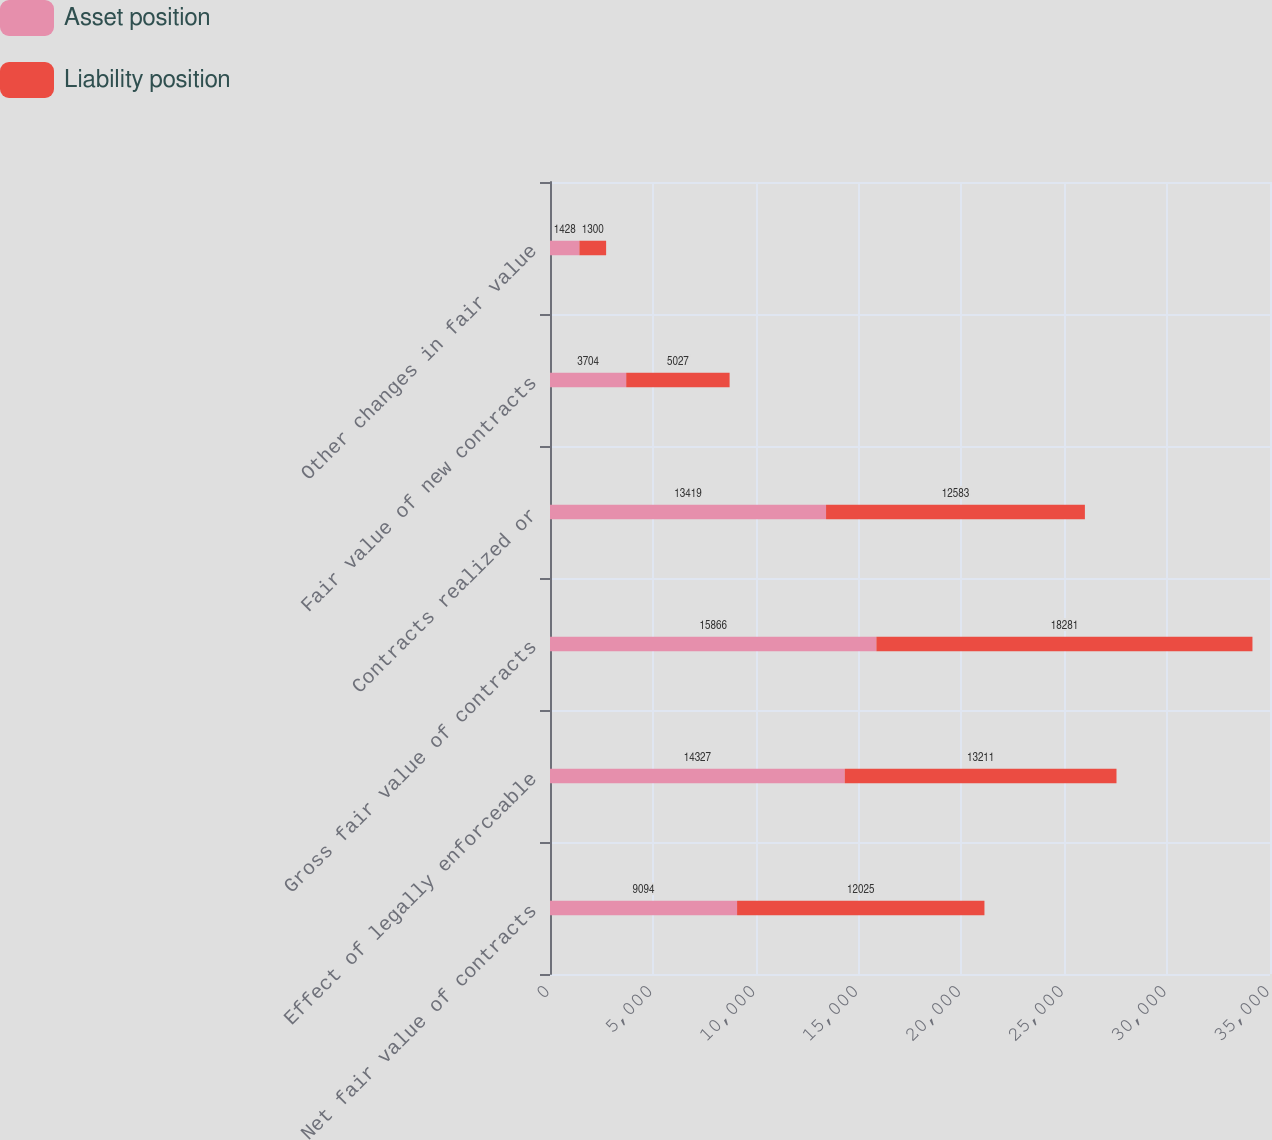Convert chart to OTSL. <chart><loc_0><loc_0><loc_500><loc_500><stacked_bar_chart><ecel><fcel>Net fair value of contracts<fcel>Effect of legally enforceable<fcel>Gross fair value of contracts<fcel>Contracts realized or<fcel>Fair value of new contracts<fcel>Other changes in fair value<nl><fcel>Asset position<fcel>9094<fcel>14327<fcel>15866<fcel>13419<fcel>3704<fcel>1428<nl><fcel>Liability position<fcel>12025<fcel>13211<fcel>18281<fcel>12583<fcel>5027<fcel>1300<nl></chart> 